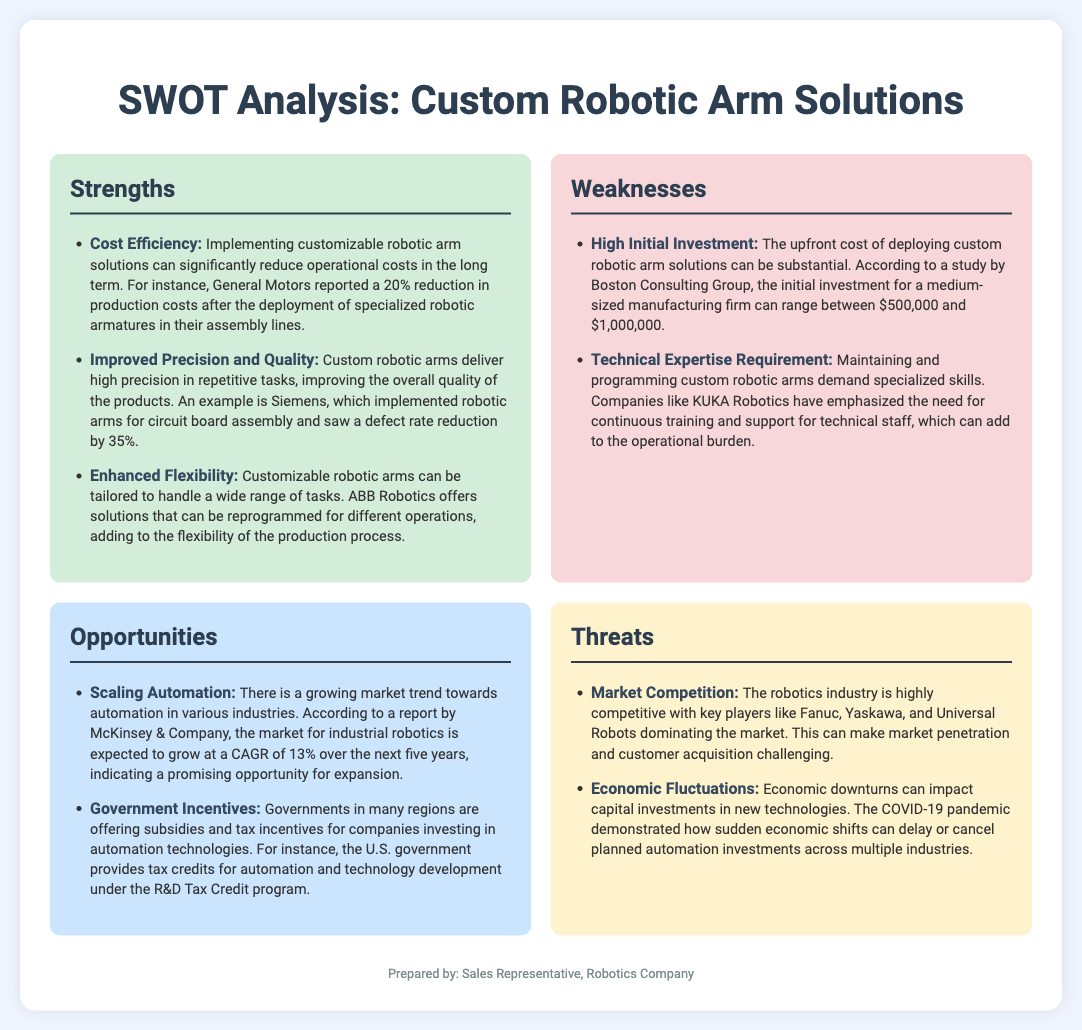What is the percentage reduction in production costs reported by General Motors? General Motors reported a 20% reduction in production costs after the deployment of specialized robotic armatures.
Answer: 20% What company saw a defect rate reduction by 35% with robotic arms? Siemens implemented robotic arms for circuit board assembly and saw a defect rate reduction by 35%.
Answer: Siemens What is the estimated initial investment range for a medium-sized manufacturing firm? The initial investment can range between $500,000 and $1,000,000 according to a study by Boston Consulting Group.
Answer: $500,000 to $1,000,000 What is the expected CAGR of the market for industrial robotics over the next five years? The market for industrial robotics is expected to grow at a CAGR of 13% over the next five years.
Answer: 13% What do governments provide for companies investing in automation technologies? Governments are offering subsidies and tax incentives for companies investing in automation technologies.
Answer: Subsidies and tax incentives Which major players are dominating the robotics market? Key players like Fanuc, Yaskawa, and Universal Robots are dominating the market.
Answer: Fanuc, Yaskawa, Universal Robots What economic event delayed or canceled planned automation investments? The COVID-19 pandemic demonstrated how sudden economic shifts can impact capital investments.
Answer: COVID-19 pandemic What does the SWOT analysis categorize as a weakness related to robotic arm solutions? The upfront cost of deploying custom robotic arm solutions can be substantial.
Answer: High Initial Investment 